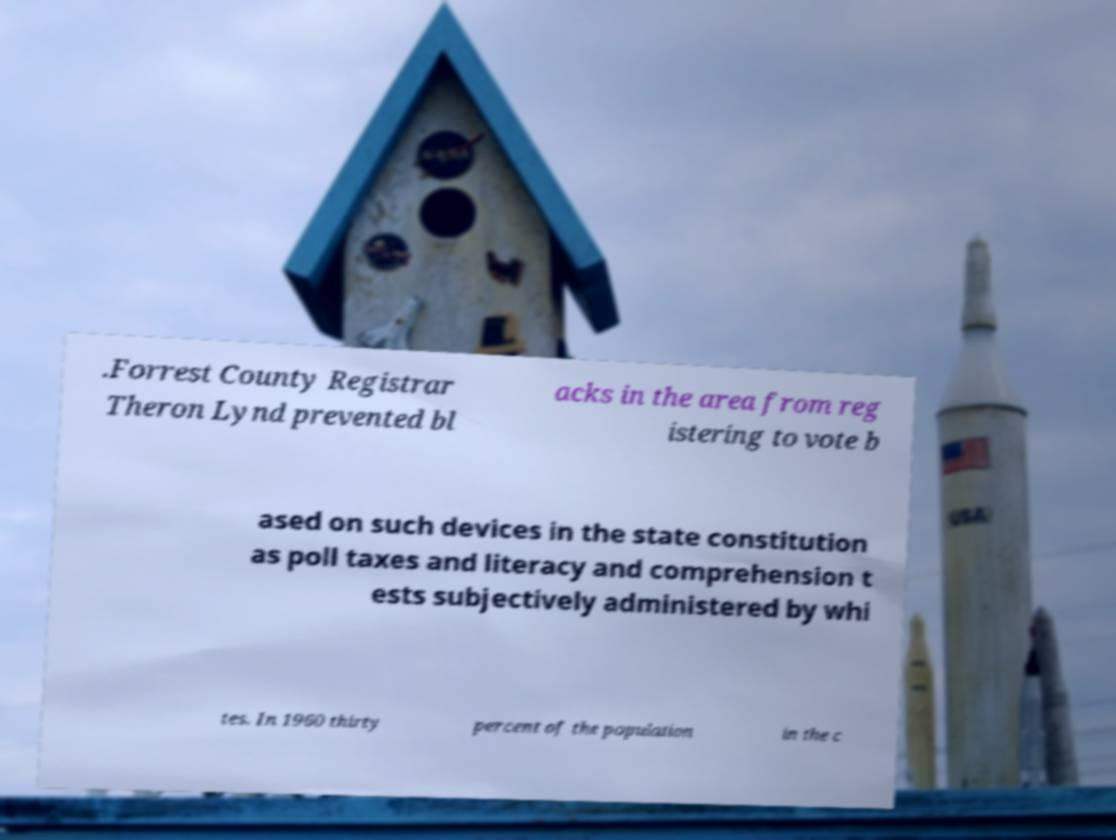Can you accurately transcribe the text from the provided image for me? .Forrest County Registrar Theron Lynd prevented bl acks in the area from reg istering to vote b ased on such devices in the state constitution as poll taxes and literacy and comprehension t ests subjectively administered by whi tes. In 1960 thirty percent of the population in the c 